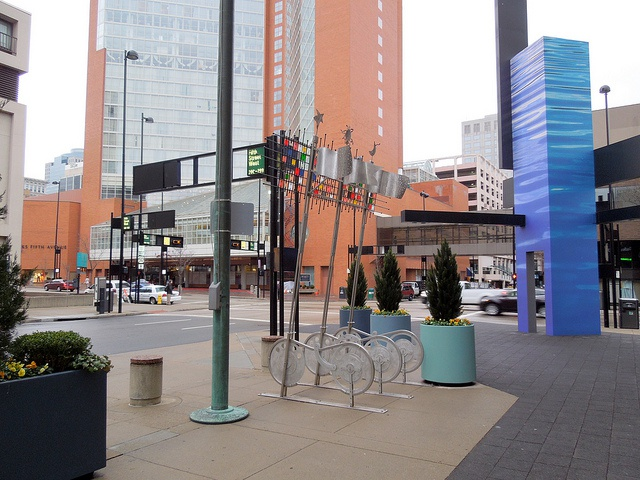Describe the objects in this image and their specific colors. I can see potted plant in lightgray, black, gray, darkgreen, and darkgray tones, potted plant in lightgray, black, teal, and gray tones, potted plant in lightgray, black, and gray tones, potted plant in lightgray, black, gray, and darkblue tones, and car in lightgray, black, darkgray, and gray tones in this image. 